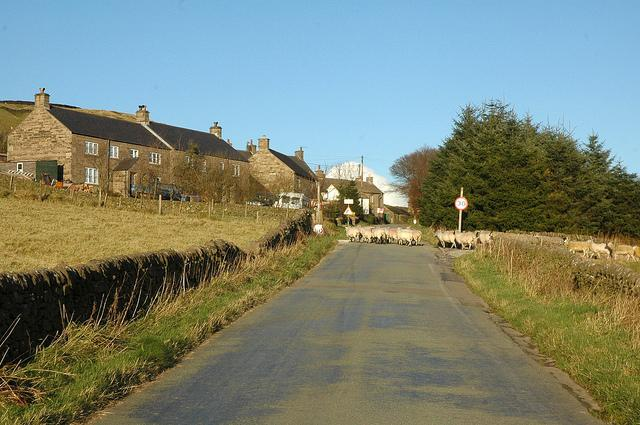When travelling this road for safety what should you allow to cross first? Please explain your reasoning. sheep. The sheep have to cross before anyone else can. 